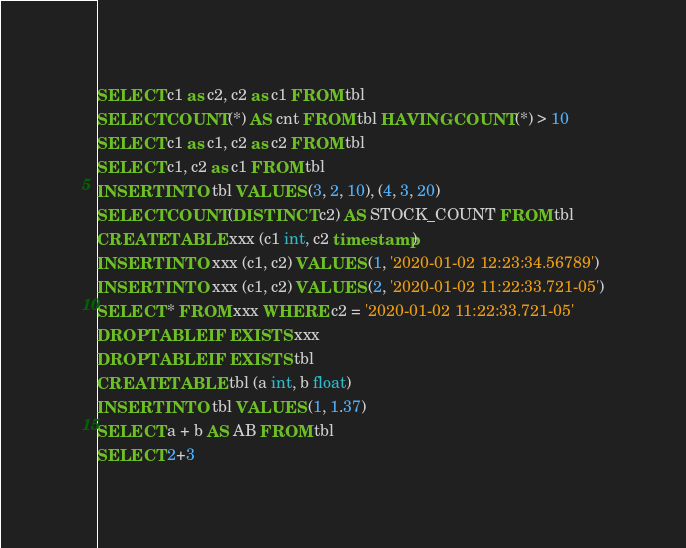Convert code to text. <code><loc_0><loc_0><loc_500><loc_500><_SQL_>SELECT c1 as c2, c2 as c1 FROM tbl
SELECT COUNT(*) AS cnt FROM tbl HAVING COUNT(*) > 10
SELECT c1 as c1, c2 as c2 FROM tbl
SELECT c1, c2 as c1 FROM tbl
INSERT INTO tbl VALUES (3, 2, 10), (4, 3, 20)
SELECT COUNT(DISTINCT c2) AS STOCK_COUNT FROM tbl
CREATE TABLE xxx (c1 int, c2 timestamp)
INSERT INTO xxx (c1, c2) VALUES (1, '2020-01-02 12:23:34.56789')
INSERT INTO xxx (c1, c2) VALUES (2, '2020-01-02 11:22:33.721-05')
SELECT * FROM xxx WHERE c2 = '2020-01-02 11:22:33.721-05'
DROP TABLE IF EXISTS xxx
DROP TABLE IF EXISTS tbl
CREATE TABLE tbl (a int, b float)
INSERT INTO tbl VALUES (1, 1.37)
SELECT a + b AS AB FROM tbl
SELECT 2+3</code> 